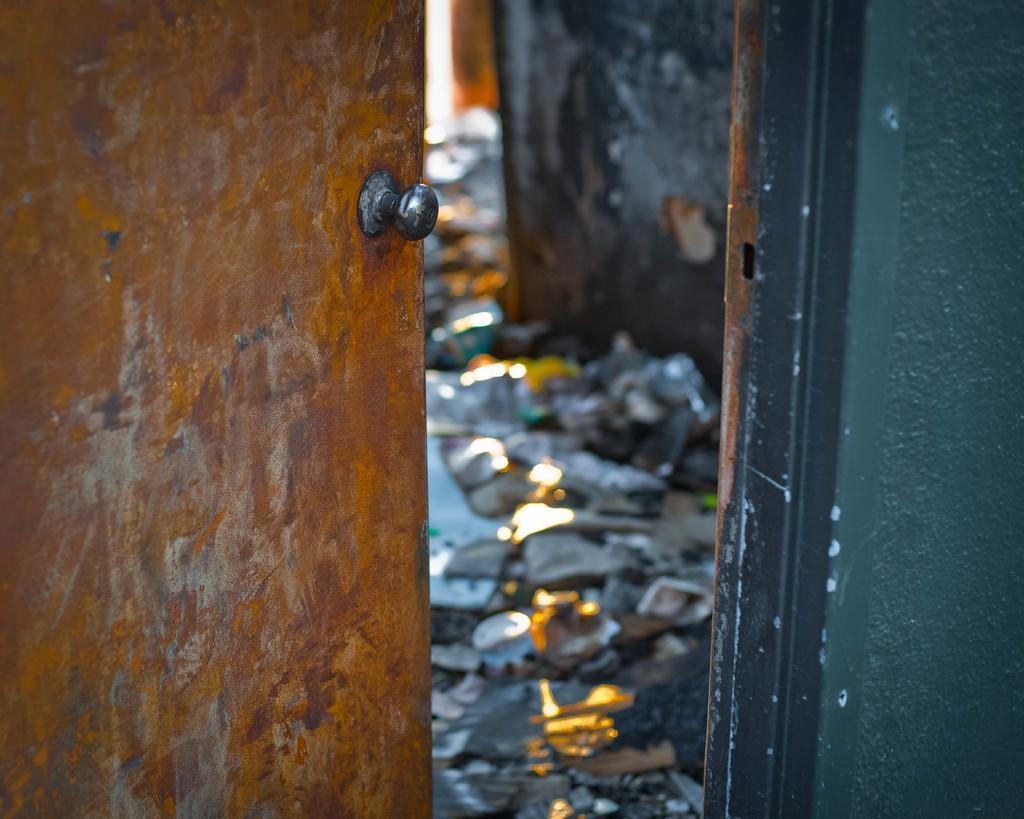How would you summarize this image in a sentence or two? This is door and there is a wall. Here we can see wastage on the floor. 